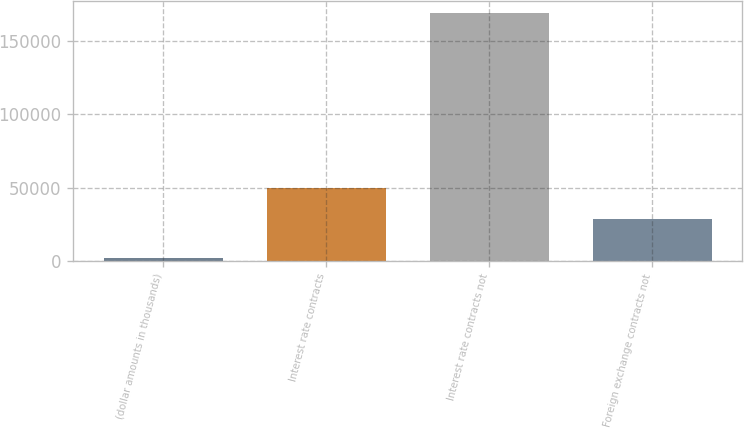Convert chart. <chart><loc_0><loc_0><loc_500><loc_500><bar_chart><fcel>(dollar amounts in thousands)<fcel>Interest rate contracts<fcel>Interest rate contracts not<fcel>Foreign exchange contracts not<nl><fcel>2013<fcel>49998<fcel>169047<fcel>28499<nl></chart> 